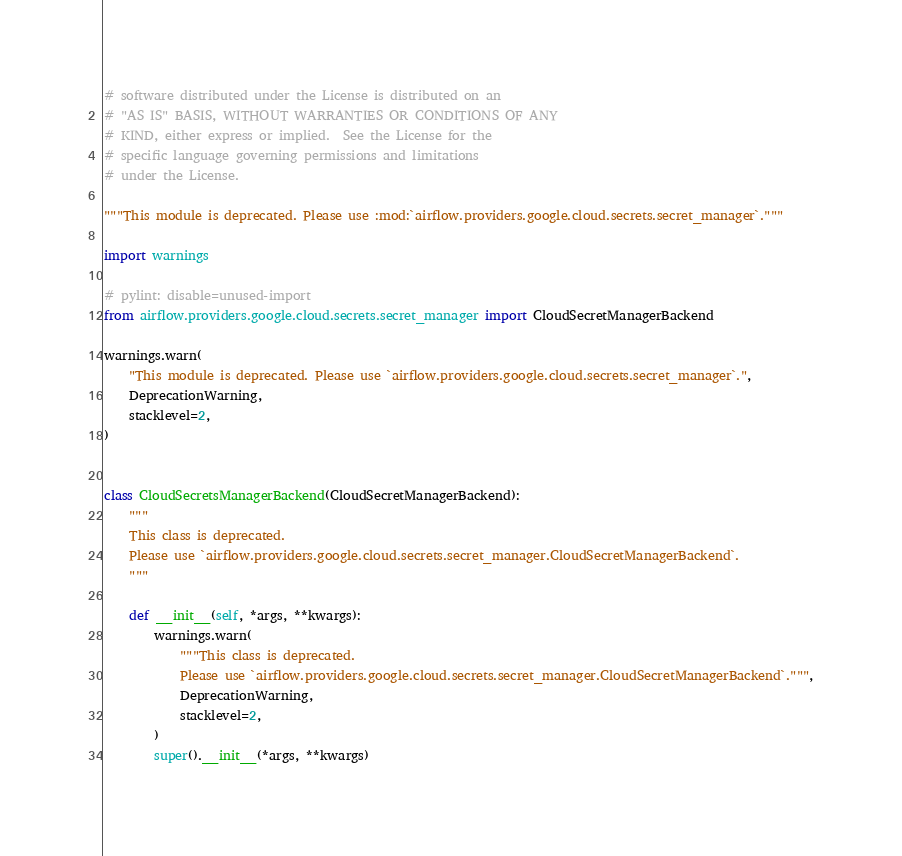<code> <loc_0><loc_0><loc_500><loc_500><_Python_># software distributed under the License is distributed on an
# "AS IS" BASIS, WITHOUT WARRANTIES OR CONDITIONS OF ANY
# KIND, either express or implied.  See the License for the
# specific language governing permissions and limitations
# under the License.

"""This module is deprecated. Please use :mod:`airflow.providers.google.cloud.secrets.secret_manager`."""

import warnings

# pylint: disable=unused-import
from airflow.providers.google.cloud.secrets.secret_manager import CloudSecretManagerBackend

warnings.warn(
    "This module is deprecated. Please use `airflow.providers.google.cloud.secrets.secret_manager`.",
    DeprecationWarning,
    stacklevel=2,
)


class CloudSecretsManagerBackend(CloudSecretManagerBackend):
    """
    This class is deprecated.
    Please use `airflow.providers.google.cloud.secrets.secret_manager.CloudSecretManagerBackend`.
    """

    def __init__(self, *args, **kwargs):
        warnings.warn(
            """This class is deprecated.
            Please use `airflow.providers.google.cloud.secrets.secret_manager.CloudSecretManagerBackend`.""",
            DeprecationWarning,
            stacklevel=2,
        )
        super().__init__(*args, **kwargs)
</code> 